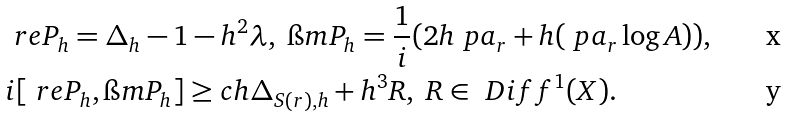<formula> <loc_0><loc_0><loc_500><loc_500>& \ r e P _ { h } = \Delta _ { h } - 1 - h ^ { 2 } \lambda , \ \i m P _ { h } = \frac { 1 } { i } ( 2 h \ p a _ { r } + h ( \ p a _ { r } \log A ) ) , \\ & i [ \ r e P _ { h } , \i m P _ { h } ] \geq c h \Delta _ { S ( r ) , h } + h ^ { 3 } R , \ R \in \ D i f f ^ { 1 } ( X ) .</formula> 